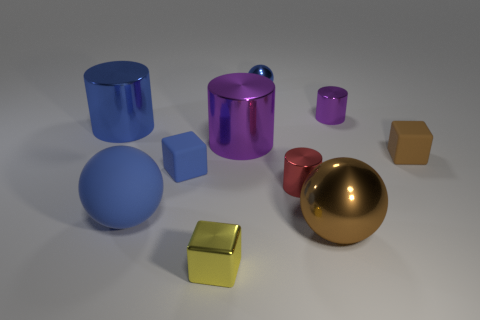What is the color of the small cylinder in front of the block that is right of the metallic sphere that is behind the big shiny ball?
Ensure brevity in your answer.  Red. How many other objects are there of the same size as the yellow metallic block?
Offer a very short reply. 5. Is there anything else that is the same shape as the big purple thing?
Ensure brevity in your answer.  Yes. There is another large metal object that is the same shape as the large purple thing; what is its color?
Offer a very short reply. Blue. There is a small cube that is the same material as the small red cylinder; what is its color?
Offer a terse response. Yellow. Are there an equal number of small metallic objects behind the large brown ball and big red metal cylinders?
Your answer should be compact. No. Do the cylinder that is in front of the brown matte object and the small brown object have the same size?
Offer a very short reply. Yes. What color is the shiny sphere that is the same size as the metallic cube?
Make the answer very short. Blue. Are there any matte balls right of the big ball to the left of the metal sphere that is right of the tiny metallic ball?
Your answer should be compact. No. What material is the cylinder that is on the left side of the large purple cylinder?
Offer a terse response. Metal. 